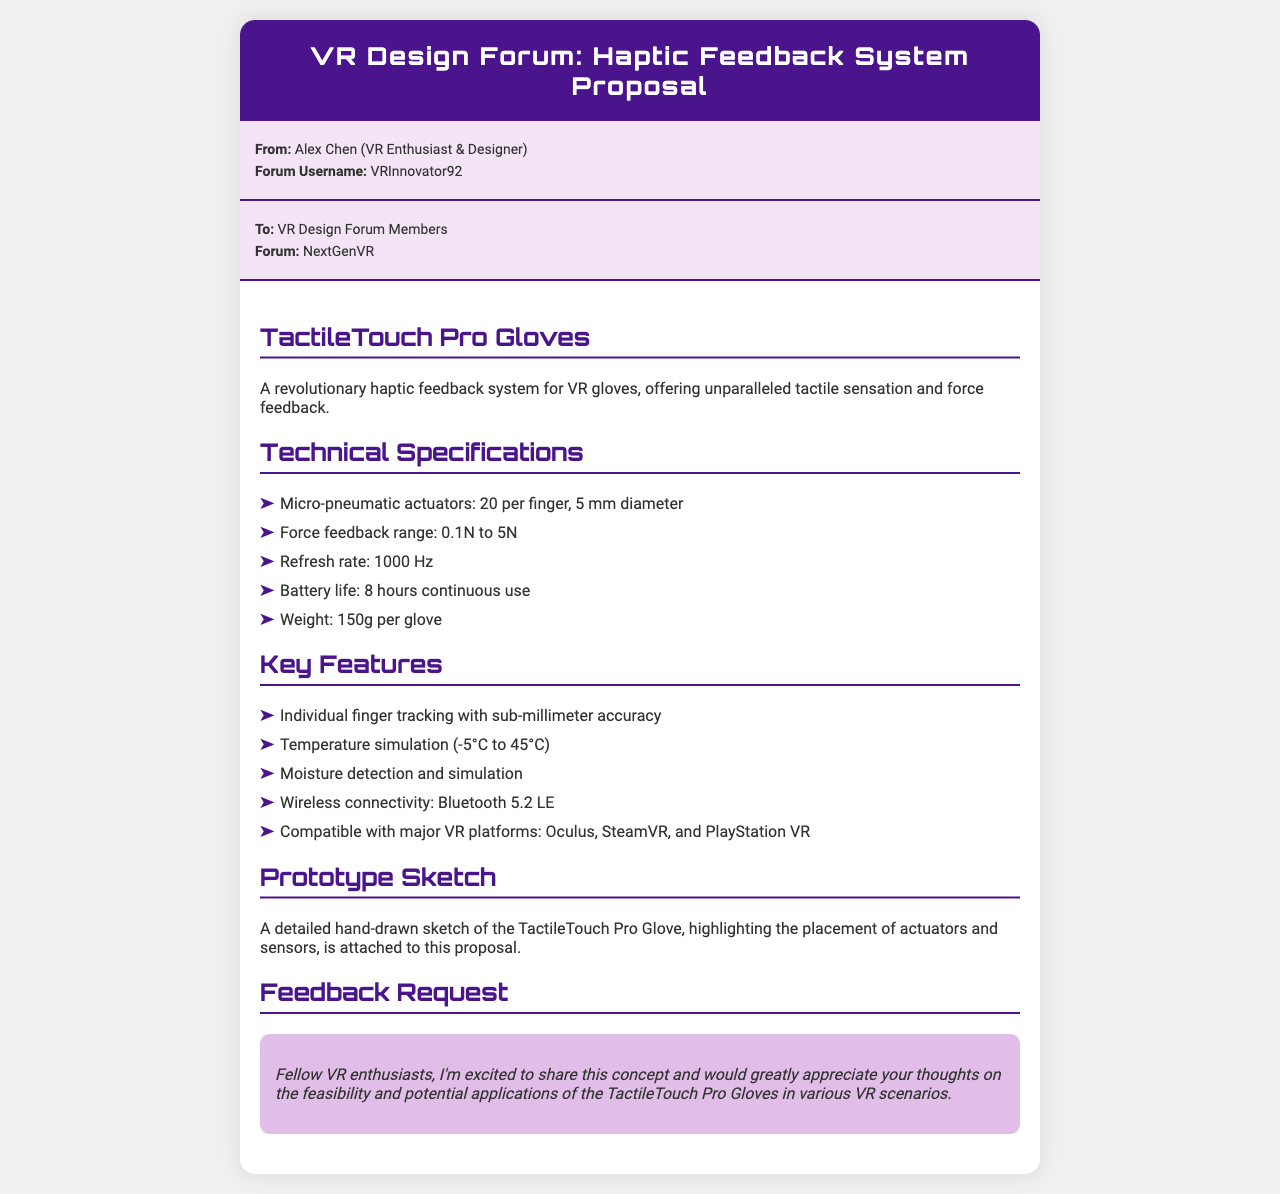What is the name of the haptic feedback system? The name of the haptic feedback system is mentioned in the document as "TactileTouch Pro Gloves."
Answer: TactileTouch Pro Gloves How many micro-pneumatic actuators are there per finger? The document specifies that there are "20 per finger" concerning micro-pneumatic actuators.
Answer: 20 What is the force feedback range of the gloves? The force feedback range mentioned in the document is "0.1N to 5N."
Answer: 0.1N to 5N What is the refresh rate of the system? The refresh rate is specified in the document as "1000 Hz."
Answer: 1000 Hz What is the battery life of the gloves? The battery life is indicated to be "8 hours continuous use."
Answer: 8 hours What connectivity technology do the gloves use? The document states that the gloves use "Bluetooth 5.2 LE" for wireless connectivity.
Answer: Bluetooth 5.2 LE What temperatures can the gloves simulate? The document mentions that temperatures can be simulated ranging from "-5°C to 45°C."
Answer: -5°C to 45°C What feature allows individual finger tracking? The document describes a feature of "sub-millimeter accuracy" for individual finger tracking.
Answer: sub-millimeter accuracy What is the weight of each glove? The document specifies the weight as "150g per glove."
Answer: 150g per glove 